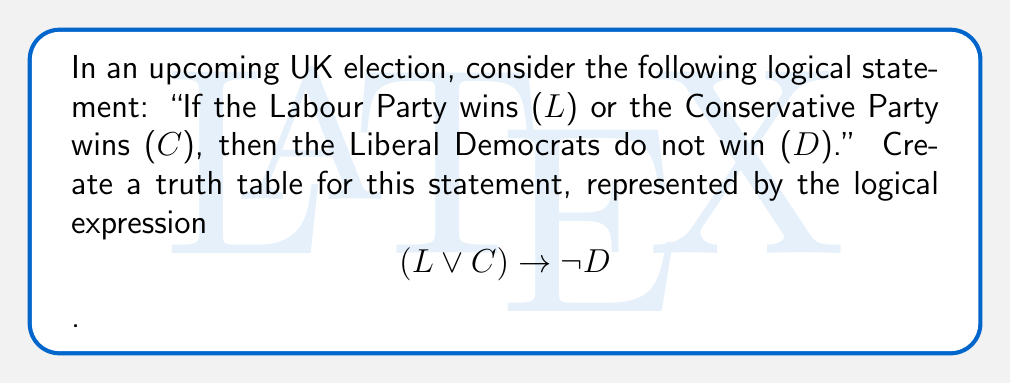What is the answer to this math problem? To create a truth table for the given logical statement, we'll follow these steps:

1. Identify the variables: L (Labour wins), C (Conservative wins), D (Liberal Democrats win)
2. List all possible combinations of truth values for these variables
3. Evaluate the subexpressions
4. Determine the final truth value of the entire expression

Step 1: The truth table will have 8 rows (2^3 combinations) for L, C, and D.

Step 2: List all combinations:
$$\begin{array}{|c|c|c|}
\hline
L & C & D \\
\hline
T & T & T \\
T & T & F \\
T & F & T \\
T & F & F \\
F & T & T \\
F & T & F \\
F & F & T \\
F & F & F \\
\hline
\end{array}$$

Step 3: Evaluate subexpressions:
a) $L \lor C$
b) $\neg D$

Step 4: Determine the final truth value of $(L \lor C) \rightarrow \neg D$

The completed truth table:

$$\begin{array}{|c|c|c|c|c|c|}
\hline
L & C & D & L \lor C & \neg D & (L \lor C) \rightarrow \neg D \\
\hline
T & T & T & T & F & F \\
T & T & F & T & T & T \\
T & F & T & T & F & F \\
T & F & F & T & T & T \\
F & T & T & T & F & F \\
F & T & F & T & T & T \\
F & F & T & F & F & T \\
F & F & F & F & T & T \\
\hline
\end{array}$$

The final column shows the truth values for the entire logical statement.
Answer: $$\begin{array}{|c|c|c|c|}
\hline
L & C & D & (L \lor C) \rightarrow \neg D \\
\hline
T & T & T & F \\
T & T & F & T \\
T & F & T & F \\
T & F & F & T \\
F & T & T & F \\
F & T & F & T \\
F & F & T & T \\
F & F & F & T \\
\hline
\end{array}$$ 